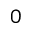Convert formula to latex. <formula><loc_0><loc_0><loc_500><loc_500>0</formula> 